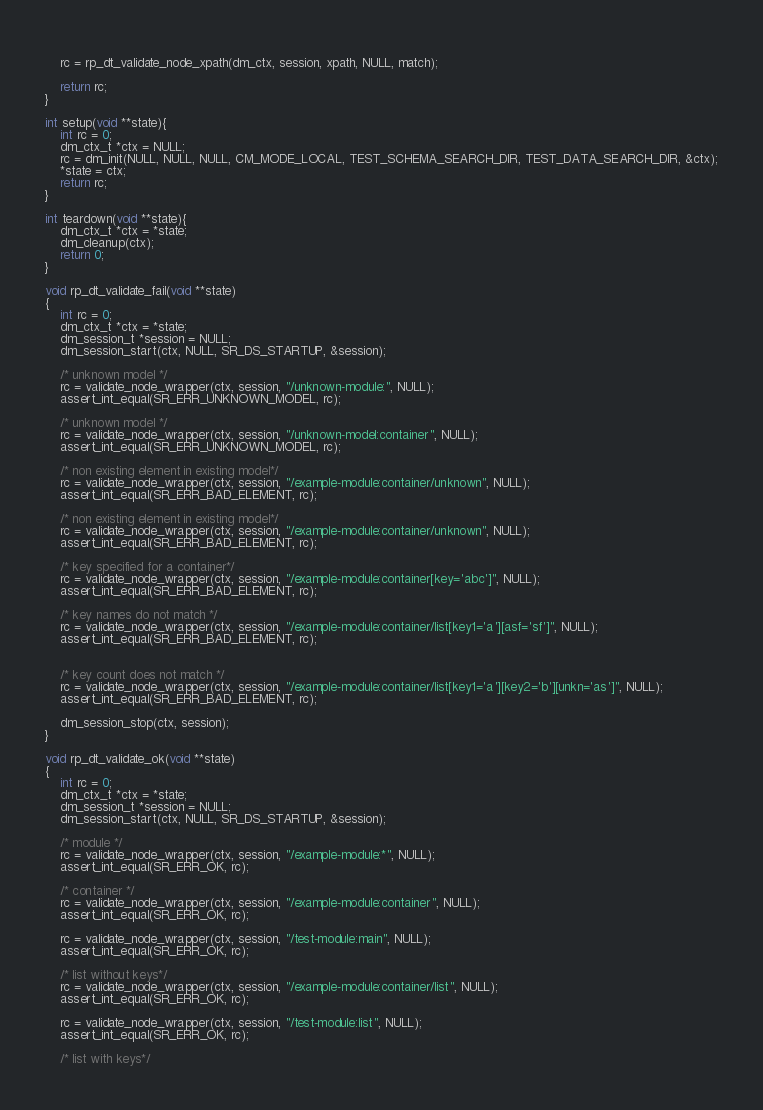<code> <loc_0><loc_0><loc_500><loc_500><_C_>    
    rc = rp_dt_validate_node_xpath(dm_ctx, session, xpath, NULL, match);
    
    return rc;
}

int setup(void **state){
    int rc = 0;
    dm_ctx_t *ctx = NULL;
    rc = dm_init(NULL, NULL, NULL, CM_MODE_LOCAL, TEST_SCHEMA_SEARCH_DIR, TEST_DATA_SEARCH_DIR, &ctx);
    *state = ctx;
    return rc;
}

int teardown(void **state){
    dm_ctx_t *ctx = *state;
    dm_cleanup(ctx);
    return 0;
}

void rp_dt_validate_fail(void **state)
{
    int rc = 0;
    dm_ctx_t *ctx = *state;
    dm_session_t *session = NULL;
    dm_session_start(ctx, NULL, SR_DS_STARTUP, &session);

    /* unknown model */
    rc = validate_node_wrapper(ctx, session, "/unknown-module:", NULL);
    assert_int_equal(SR_ERR_UNKNOWN_MODEL, rc);

    /* unknown model */
    rc = validate_node_wrapper(ctx, session, "/unknown-model:container", NULL);
    assert_int_equal(SR_ERR_UNKNOWN_MODEL, rc);

    /* non existing element in existing model*/
    rc = validate_node_wrapper(ctx, session, "/example-module:container/unknown", NULL);
    assert_int_equal(SR_ERR_BAD_ELEMENT, rc);

    /* non existing element in existing model*/
    rc = validate_node_wrapper(ctx, session, "/example-module:container/unknown", NULL);
    assert_int_equal(SR_ERR_BAD_ELEMENT, rc);

    /* key specified for a container*/
    rc = validate_node_wrapper(ctx, session, "/example-module:container[key='abc']", NULL);
    assert_int_equal(SR_ERR_BAD_ELEMENT, rc);

    /* key names do not match */
    rc = validate_node_wrapper(ctx, session, "/example-module:container/list[key1='a'][asf='sf']", NULL);
    assert_int_equal(SR_ERR_BAD_ELEMENT, rc);

    
    /* key count does not match */
    rc = validate_node_wrapper(ctx, session, "/example-module:container/list[key1='a'][key2='b'][unkn='as']", NULL);
    assert_int_equal(SR_ERR_BAD_ELEMENT, rc);

    dm_session_stop(ctx, session);
}

void rp_dt_validate_ok(void **state)
{
    int rc = 0;
    dm_ctx_t *ctx = *state;
    dm_session_t *session = NULL;
    dm_session_start(ctx, NULL, SR_DS_STARTUP, &session);

    /* module */
    rc = validate_node_wrapper(ctx, session, "/example-module:*", NULL);
    assert_int_equal(SR_ERR_OK, rc);

    /* container */
    rc = validate_node_wrapper(ctx, session, "/example-module:container", NULL);
    assert_int_equal(SR_ERR_OK, rc);

    rc = validate_node_wrapper(ctx, session, "/test-module:main", NULL);
    assert_int_equal(SR_ERR_OK, rc);

    /* list without keys*/
    rc = validate_node_wrapper(ctx, session, "/example-module:container/list", NULL);
    assert_int_equal(SR_ERR_OK, rc);

    rc = validate_node_wrapper(ctx, session, "/test-module:list", NULL);
    assert_int_equal(SR_ERR_OK, rc);

    /* list with keys*/</code> 